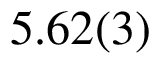<formula> <loc_0><loc_0><loc_500><loc_500>5 . 6 2 ( 3 )</formula> 